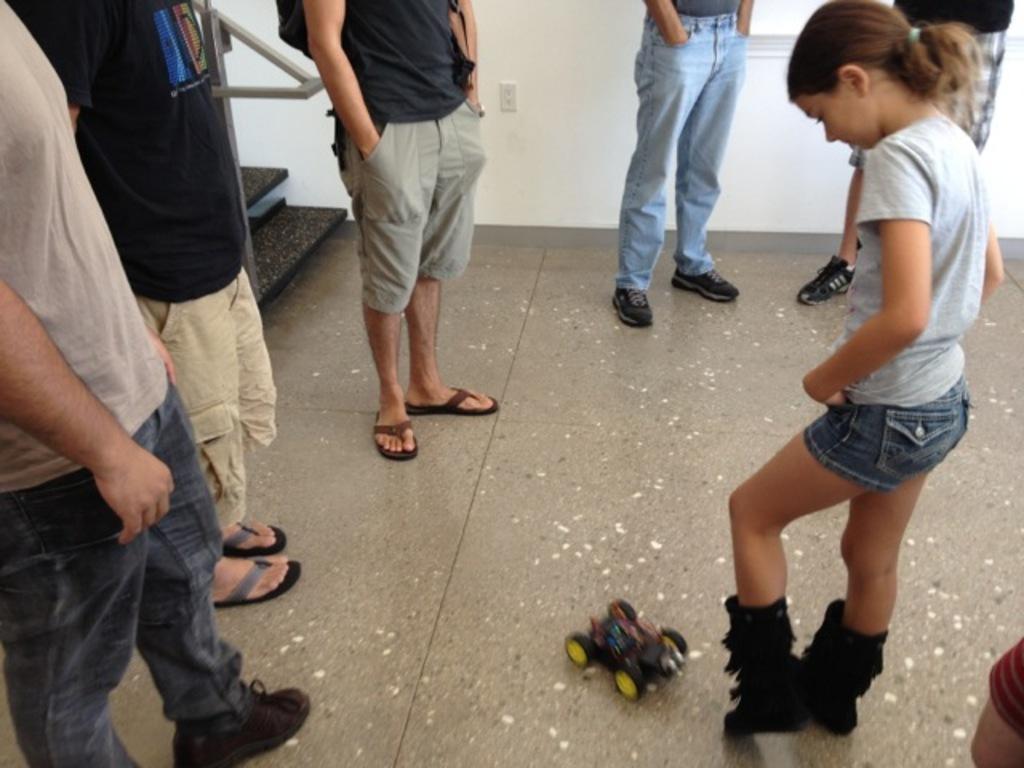In one or two sentences, can you explain what this image depicts? In this picture there are group of people standing and there is a toy on the floor. At the back there is a staircase and there is a hand rail and it looks like a window. 